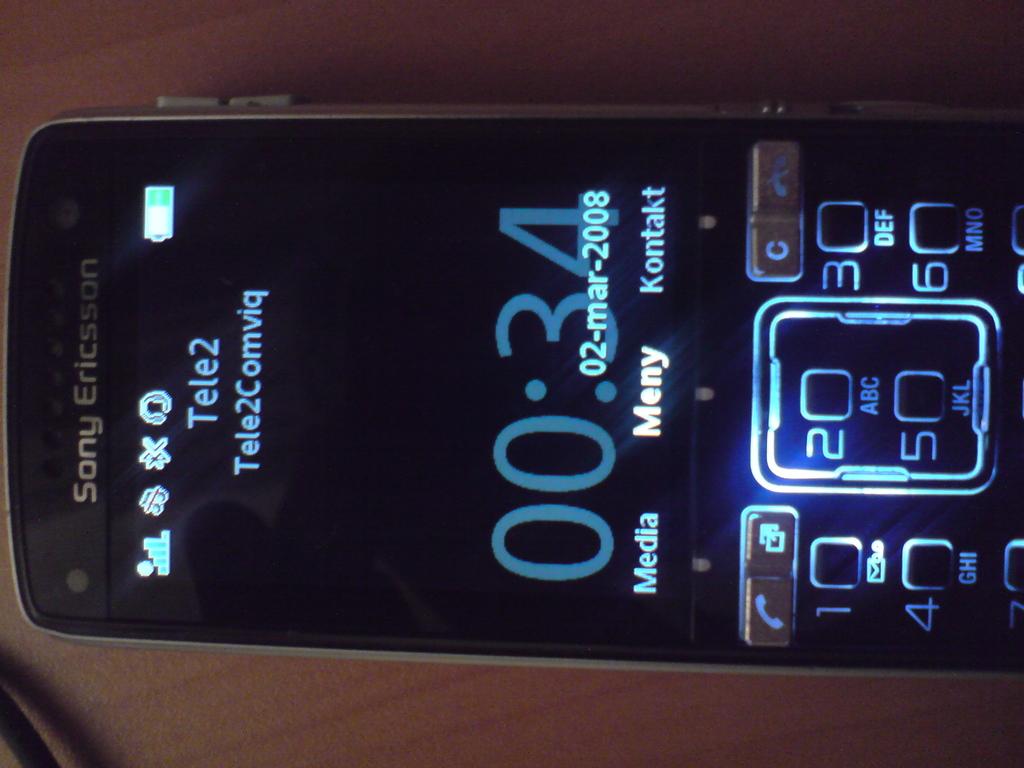What is the time / numbers on the bottom of the phone screen?
Make the answer very short. 00:34. 